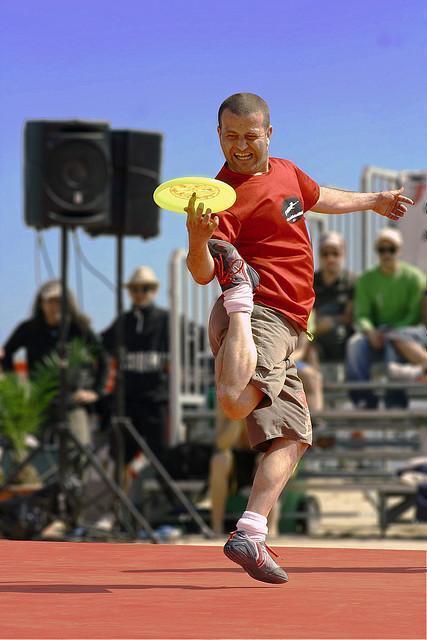How many people are in the background?
Give a very brief answer. 4. How many people are there?
Give a very brief answer. 5. 